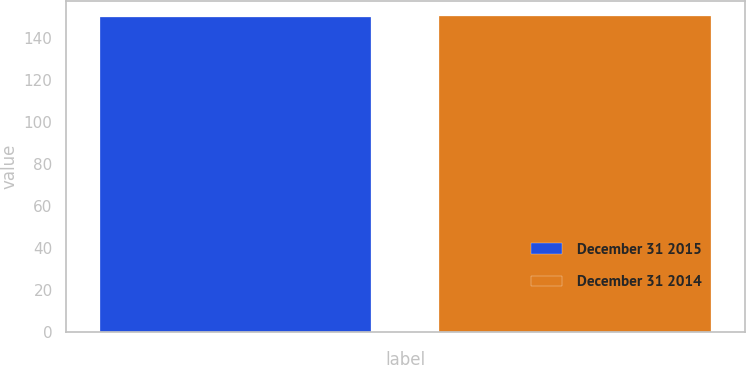<chart> <loc_0><loc_0><loc_500><loc_500><bar_chart><fcel>December 31 2015<fcel>December 31 2014<nl><fcel>150<fcel>150.1<nl></chart> 